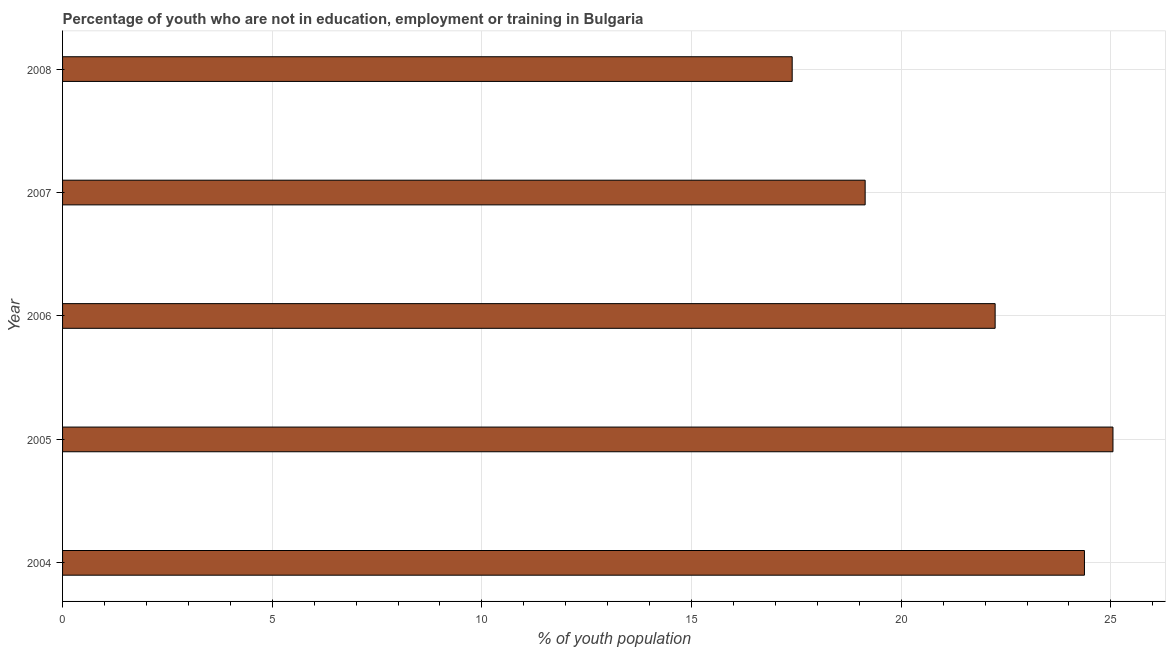Does the graph contain grids?
Offer a terse response. Yes. What is the title of the graph?
Your response must be concise. Percentage of youth who are not in education, employment or training in Bulgaria. What is the label or title of the X-axis?
Your answer should be very brief. % of youth population. What is the unemployed youth population in 2004?
Provide a succinct answer. 24.37. Across all years, what is the maximum unemployed youth population?
Make the answer very short. 25.05. Across all years, what is the minimum unemployed youth population?
Your response must be concise. 17.4. In which year was the unemployed youth population minimum?
Keep it short and to the point. 2008. What is the sum of the unemployed youth population?
Make the answer very short. 108.2. What is the difference between the unemployed youth population in 2004 and 2008?
Give a very brief answer. 6.97. What is the average unemployed youth population per year?
Offer a terse response. 21.64. What is the median unemployed youth population?
Your answer should be compact. 22.24. In how many years, is the unemployed youth population greater than 7 %?
Make the answer very short. 5. Do a majority of the years between 2007 and 2005 (inclusive) have unemployed youth population greater than 21 %?
Ensure brevity in your answer.  Yes. What is the ratio of the unemployed youth population in 2005 to that in 2006?
Ensure brevity in your answer.  1.13. Is the unemployed youth population in 2006 less than that in 2008?
Offer a terse response. No. What is the difference between the highest and the second highest unemployed youth population?
Offer a terse response. 0.68. Is the sum of the unemployed youth population in 2006 and 2007 greater than the maximum unemployed youth population across all years?
Give a very brief answer. Yes. What is the difference between the highest and the lowest unemployed youth population?
Your response must be concise. 7.65. In how many years, is the unemployed youth population greater than the average unemployed youth population taken over all years?
Make the answer very short. 3. How many bars are there?
Make the answer very short. 5. How many years are there in the graph?
Make the answer very short. 5. What is the % of youth population of 2004?
Your answer should be compact. 24.37. What is the % of youth population in 2005?
Offer a terse response. 25.05. What is the % of youth population of 2006?
Make the answer very short. 22.24. What is the % of youth population in 2007?
Keep it short and to the point. 19.14. What is the % of youth population in 2008?
Your answer should be compact. 17.4. What is the difference between the % of youth population in 2004 and 2005?
Give a very brief answer. -0.68. What is the difference between the % of youth population in 2004 and 2006?
Provide a succinct answer. 2.13. What is the difference between the % of youth population in 2004 and 2007?
Offer a terse response. 5.23. What is the difference between the % of youth population in 2004 and 2008?
Your response must be concise. 6.97. What is the difference between the % of youth population in 2005 and 2006?
Your answer should be compact. 2.81. What is the difference between the % of youth population in 2005 and 2007?
Keep it short and to the point. 5.91. What is the difference between the % of youth population in 2005 and 2008?
Offer a very short reply. 7.65. What is the difference between the % of youth population in 2006 and 2007?
Ensure brevity in your answer.  3.1. What is the difference between the % of youth population in 2006 and 2008?
Provide a short and direct response. 4.84. What is the difference between the % of youth population in 2007 and 2008?
Keep it short and to the point. 1.74. What is the ratio of the % of youth population in 2004 to that in 2005?
Your answer should be very brief. 0.97. What is the ratio of the % of youth population in 2004 to that in 2006?
Your response must be concise. 1.1. What is the ratio of the % of youth population in 2004 to that in 2007?
Offer a terse response. 1.27. What is the ratio of the % of youth population in 2004 to that in 2008?
Offer a very short reply. 1.4. What is the ratio of the % of youth population in 2005 to that in 2006?
Provide a succinct answer. 1.13. What is the ratio of the % of youth population in 2005 to that in 2007?
Make the answer very short. 1.31. What is the ratio of the % of youth population in 2005 to that in 2008?
Your answer should be very brief. 1.44. What is the ratio of the % of youth population in 2006 to that in 2007?
Your response must be concise. 1.16. What is the ratio of the % of youth population in 2006 to that in 2008?
Give a very brief answer. 1.28. 